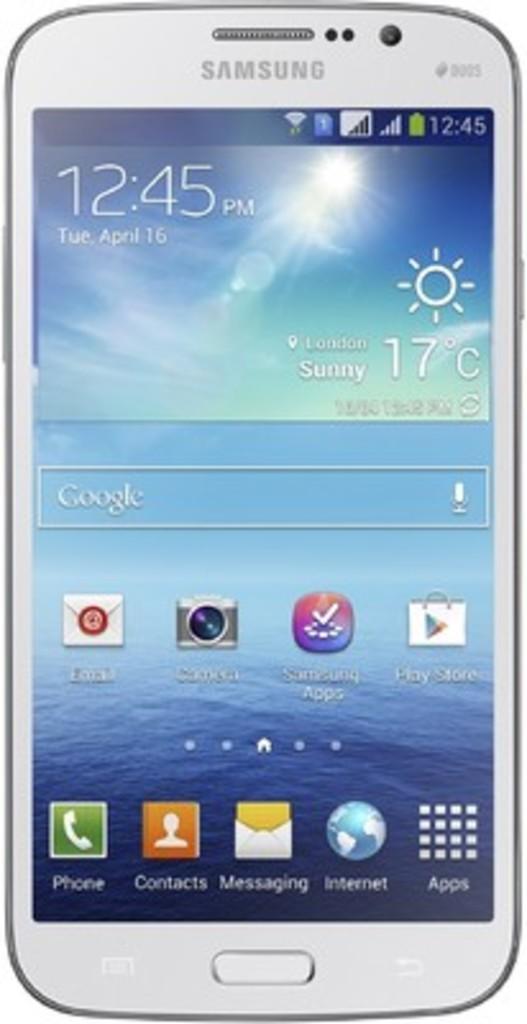What time is it on this phone?
Keep it short and to the point. 12:45. What brand is this phone?
Ensure brevity in your answer.  Samsung. 